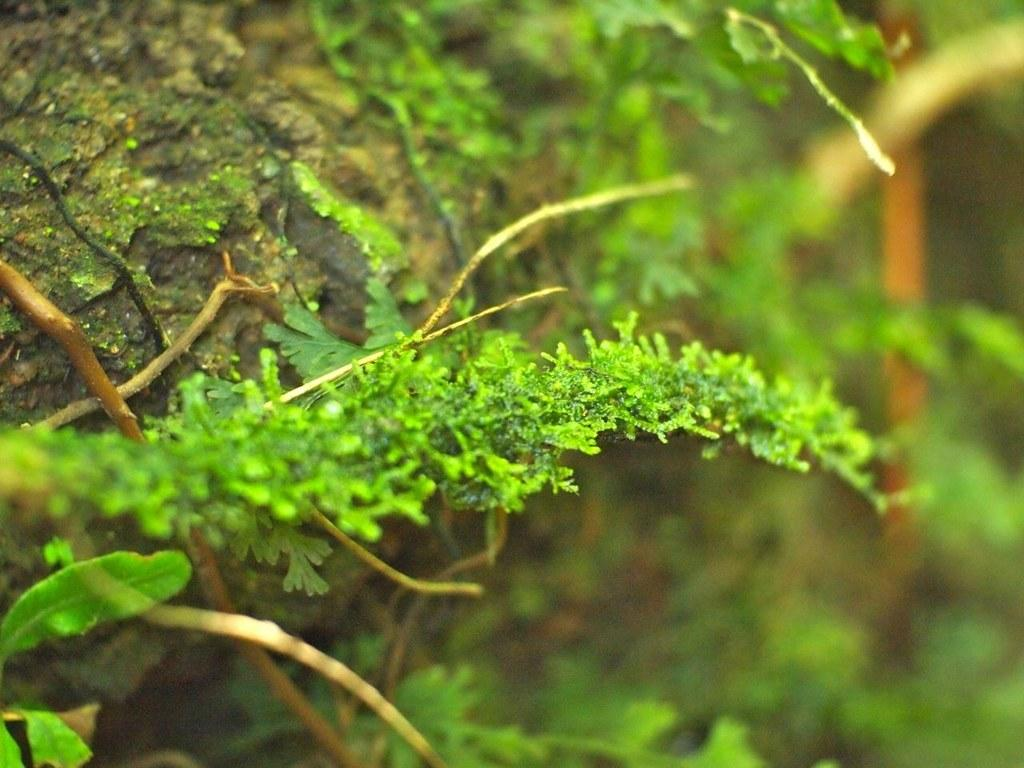What type of living organisms can be seen in the image? Plants can be seen in the image. What is visible on the left side of the image? There appears to be mud on the left side of the image. What type of support is provided by the roof in the image? There is no roof present in the image, as it only features plants and mud. 